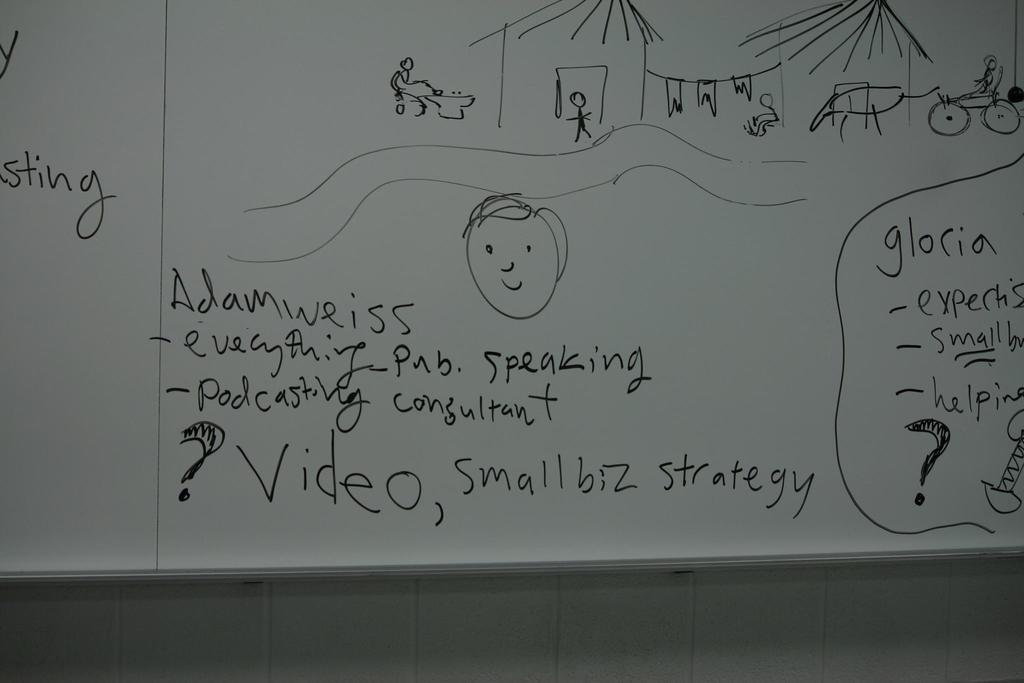What kind of strategy is shown on the bottom of the white board?
Your answer should be very brief. Small biz. 